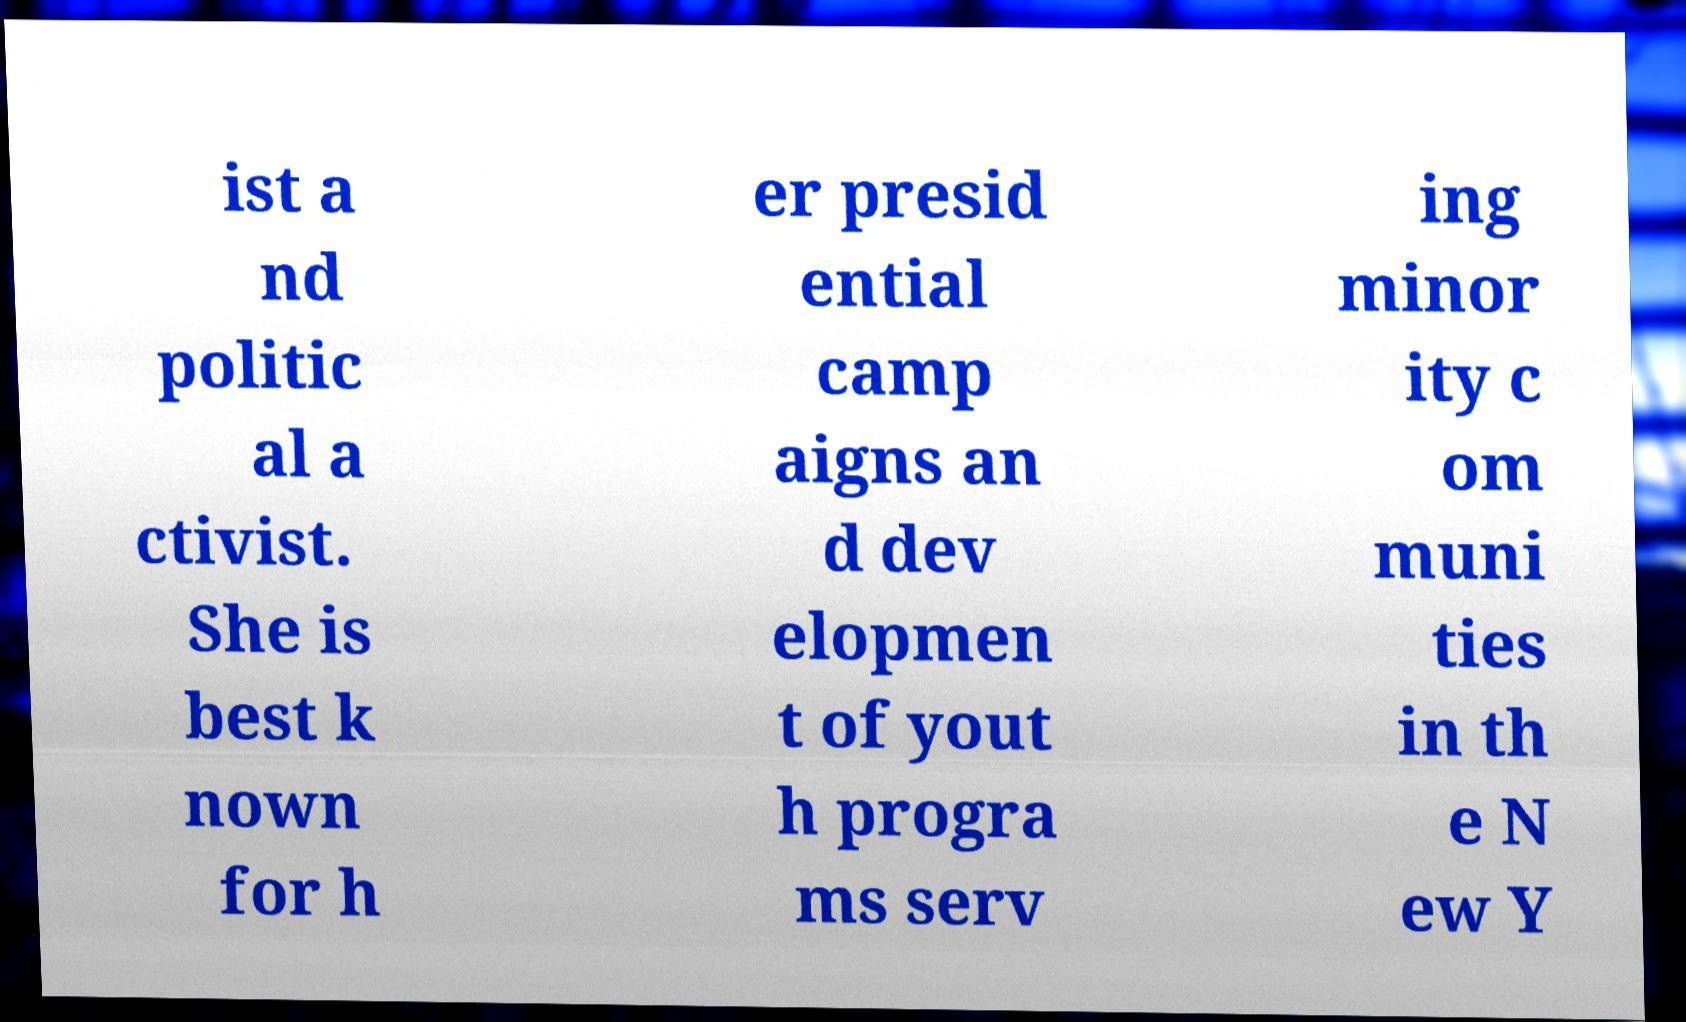What messages or text are displayed in this image? I need them in a readable, typed format. ist a nd politic al a ctivist. She is best k nown for h er presid ential camp aigns an d dev elopmen t of yout h progra ms serv ing minor ity c om muni ties in th e N ew Y 